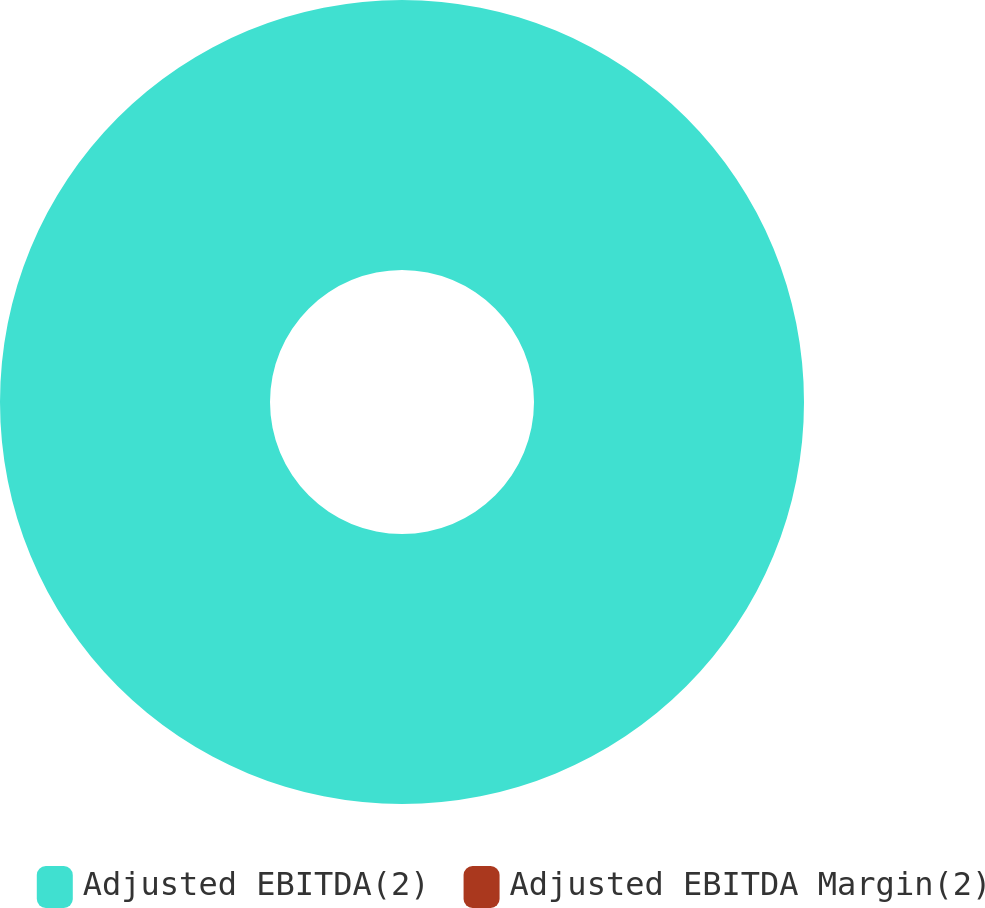Convert chart. <chart><loc_0><loc_0><loc_500><loc_500><pie_chart><fcel>Adjusted EBITDA(2)<fcel>Adjusted EBITDA Margin(2)<nl><fcel>100.0%<fcel>0.0%<nl></chart> 